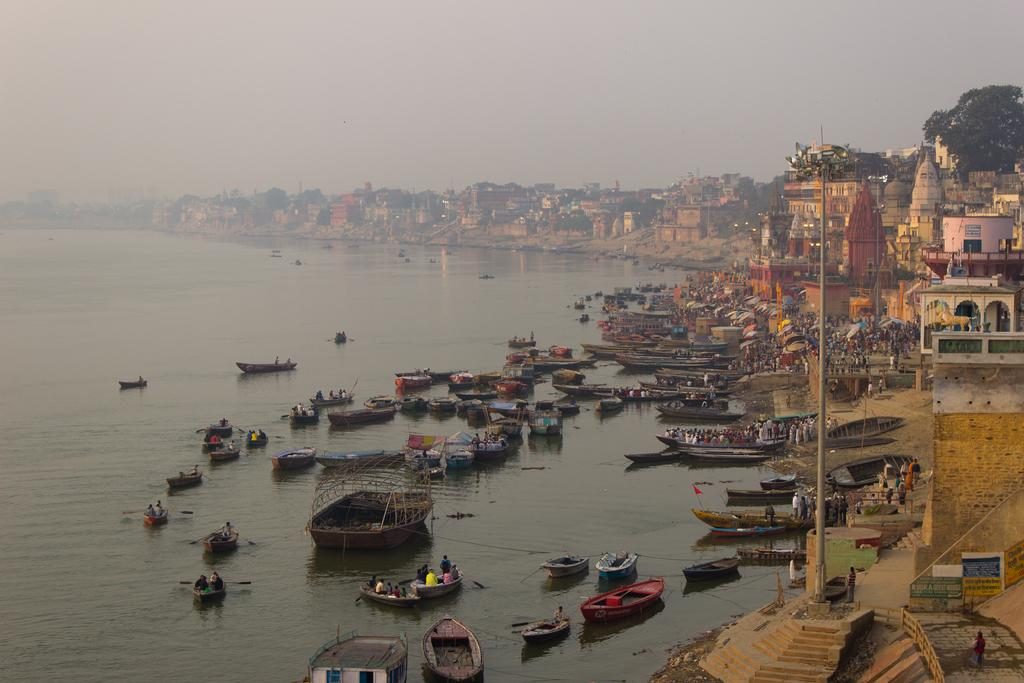What can be seen floating on the water in the image? There are boats on the water in the image. What type of structures are visible in the image? There are buildings visible in the image. Who is present in the boat? There are people in the boat. What are the people near the building doing? There are people standing near the building. What type of vegetation is present in the image? There is a tree in the image. What is the long, thin metal object in the image? There is an iron rod in the image. What is visible above the buildings and boats in the image? The sky is visible in the image. What type of polish is being applied to the floor in the image? There is no mention of polish or a floor in the image. What color are the trousers worn by the people in the boat? The image does not provide enough detail to determine the color of the trousers worn by the people in the boat. 